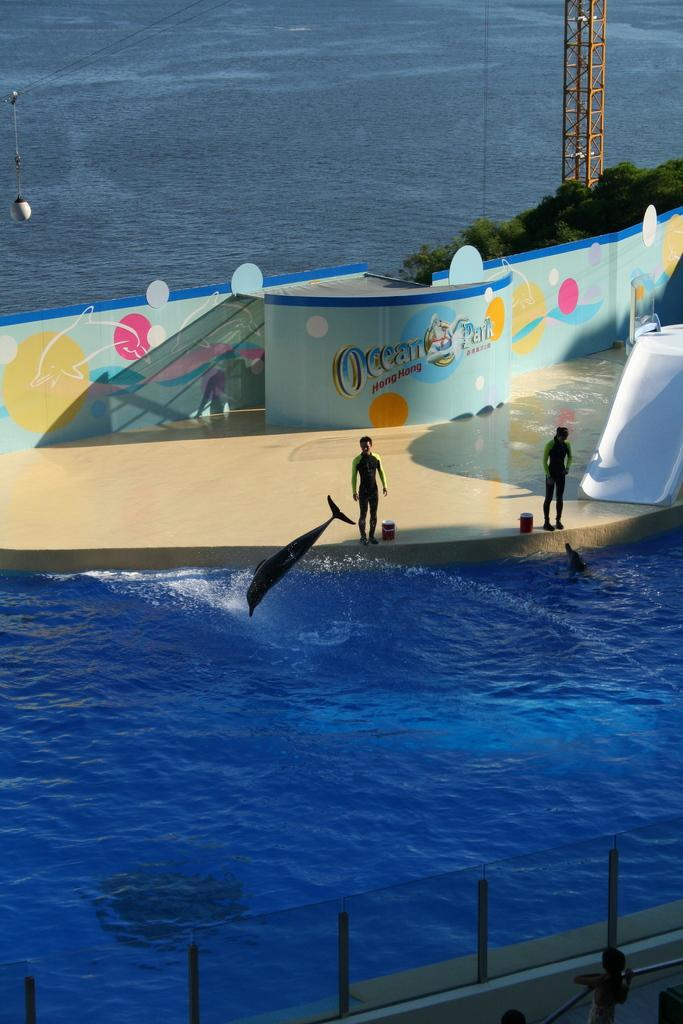What is the primary element in the image? There is water in the image. What structure is built on the water? There is a stage on the water. What are the people on the stage doing? There are people standing on the stage. Can you describe any living organisms in the image? There is a fish visible in the image. What can be seen in the background of the image? There are plants and a pole in the background of the image. How many thumbs can be seen on the people standing on the stage? There is no way to determine the number of thumbs on the people standing on the stage from the image alone. What is the desire of the fish in the image? The image does not provide any information about the desires of the fish. 